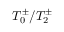<formula> <loc_0><loc_0><loc_500><loc_500>T _ { 0 } ^ { \pm } / T _ { 2 } ^ { \pm }</formula> 